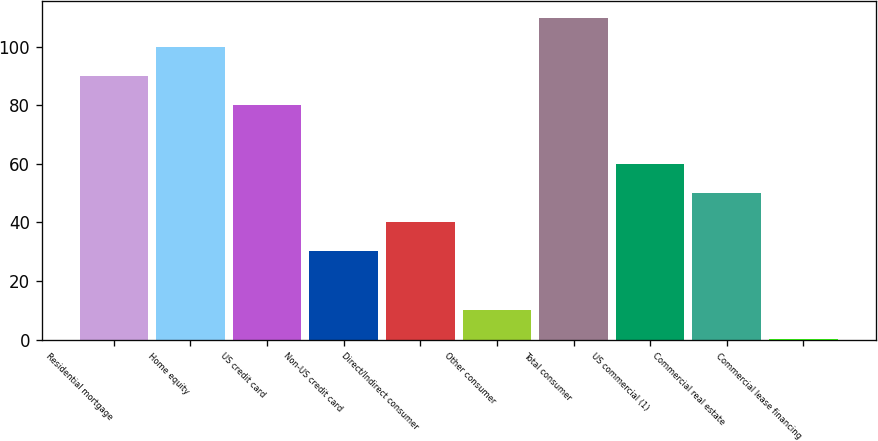<chart> <loc_0><loc_0><loc_500><loc_500><bar_chart><fcel>Residential mortgage<fcel>Home equity<fcel>US credit card<fcel>Non-US credit card<fcel>Direct/Indirect consumer<fcel>Other consumer<fcel>Total consumer<fcel>US commercial (1)<fcel>Commercial real estate<fcel>Commercial lease financing<nl><fcel>90<fcel>99.97<fcel>80.03<fcel>30.18<fcel>40.15<fcel>10.24<fcel>109.94<fcel>60.09<fcel>50.12<fcel>0.27<nl></chart> 